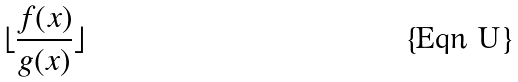<formula> <loc_0><loc_0><loc_500><loc_500>\lfloor \frac { f ( x ) } { g ( x ) } \rfloor</formula> 